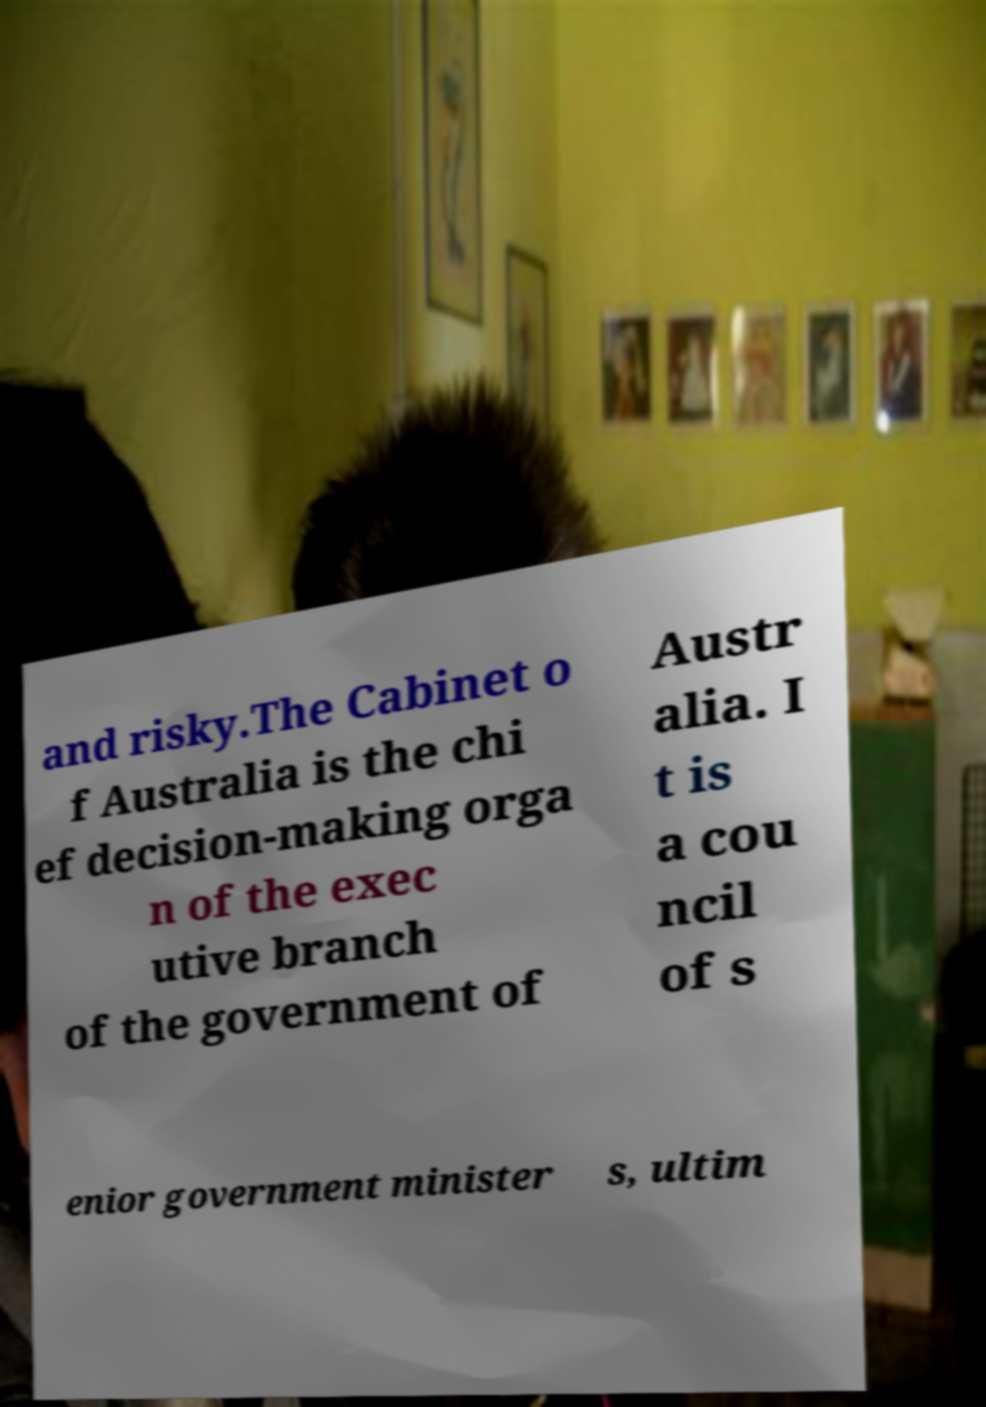Could you extract and type out the text from this image? and risky.The Cabinet o f Australia is the chi ef decision-making orga n of the exec utive branch of the government of Austr alia. I t is a cou ncil of s enior government minister s, ultim 